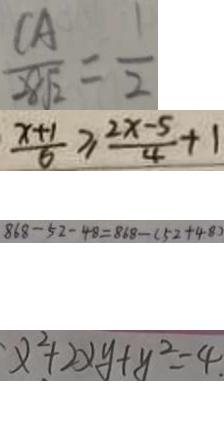Convert formula to latex. <formula><loc_0><loc_0><loc_500><loc_500>\frac { C A } { 2 8 \sqrt { 2 } } = \frac { 1 } { 2 } 
 \frac { x + 1 } { 6 } \geq \frac { 2 x - 5 } { 4 } + 1 
 8 6 8 - 5 2 - 4 8 = 8 6 8 - ( 5 2 + 4 8 ) 
 x ^ { 2 } + 2 x y + y ^ { 2 } = 4</formula> 